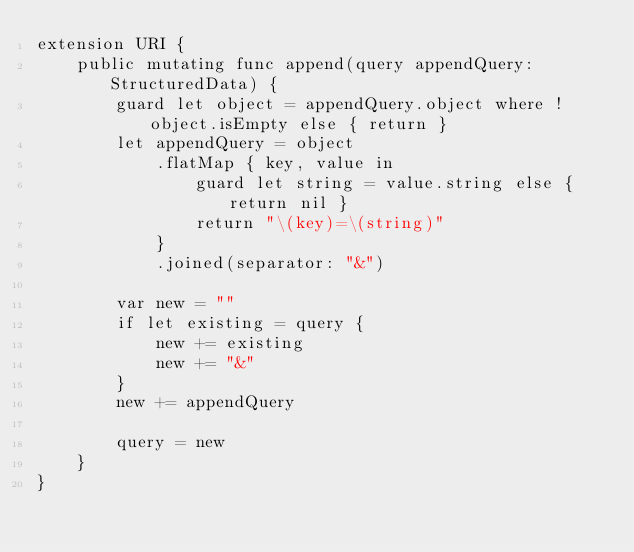Convert code to text. <code><loc_0><loc_0><loc_500><loc_500><_Swift_>extension URI {
    public mutating func append(query appendQuery: StructuredData) {
        guard let object = appendQuery.object where !object.isEmpty else { return }
        let appendQuery = object
            .flatMap { key, value in
                guard let string = value.string else { return nil }
                return "\(key)=\(string)"
            }
            .joined(separator: "&")

        var new = ""
        if let existing = query {
            new += existing
            new += "&"
        }
        new += appendQuery

        query = new
    }
}
</code> 